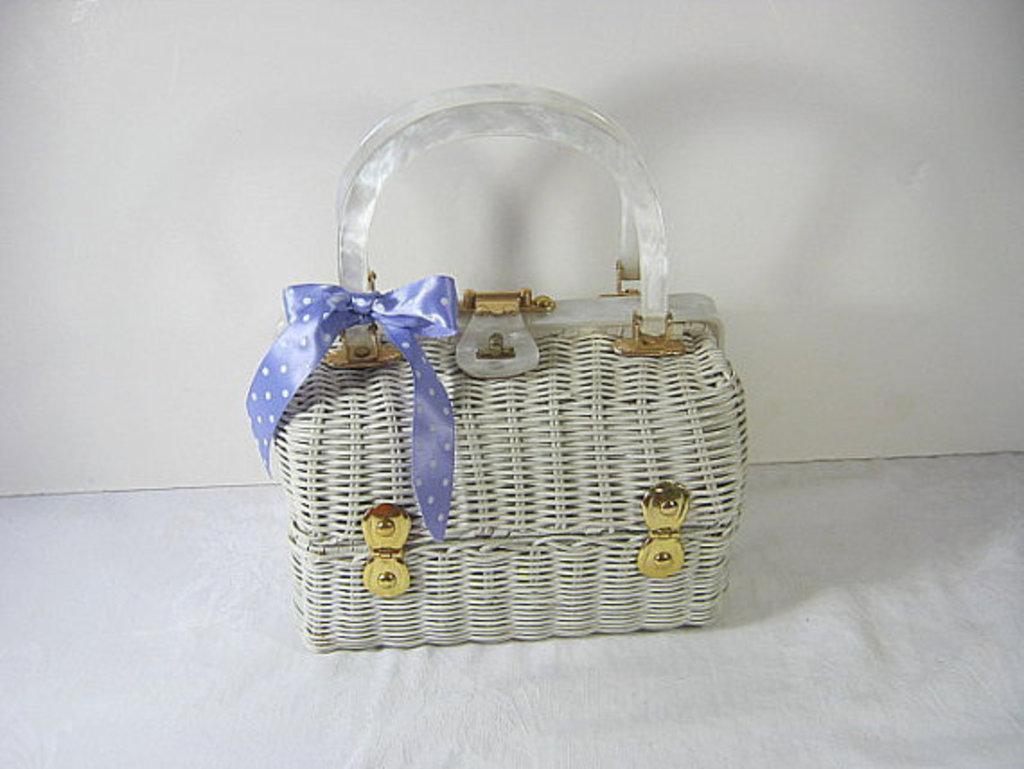Could you give a brief overview of what you see in this image? Here we see a box and we see a ribbon tied to it 